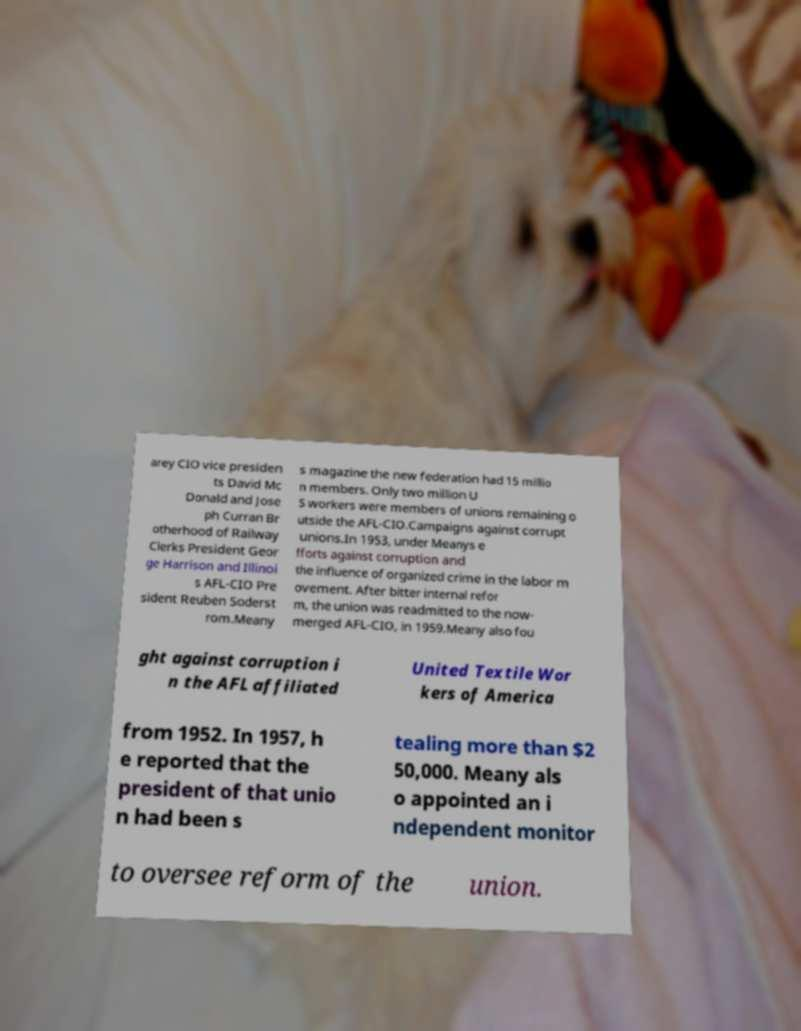Please read and relay the text visible in this image. What does it say? arey CIO vice presiden ts David Mc Donald and Jose ph Curran Br otherhood of Railway Clerks President Geor ge Harrison and Illinoi s AFL-CIO Pre sident Reuben Soderst rom.Meany s magazine the new federation had 15 millio n members. Only two million U S workers were members of unions remaining o utside the AFL-CIO.Campaigns against corrupt unions.In 1953, under Meanys e fforts against corruption and the influence of organized crime in the labor m ovement. After bitter internal refor m, the union was readmitted to the now- merged AFL-CIO, in 1959.Meany also fou ght against corruption i n the AFL affiliated United Textile Wor kers of America from 1952. In 1957, h e reported that the president of that unio n had been s tealing more than $2 50,000. Meany als o appointed an i ndependent monitor to oversee reform of the union. 